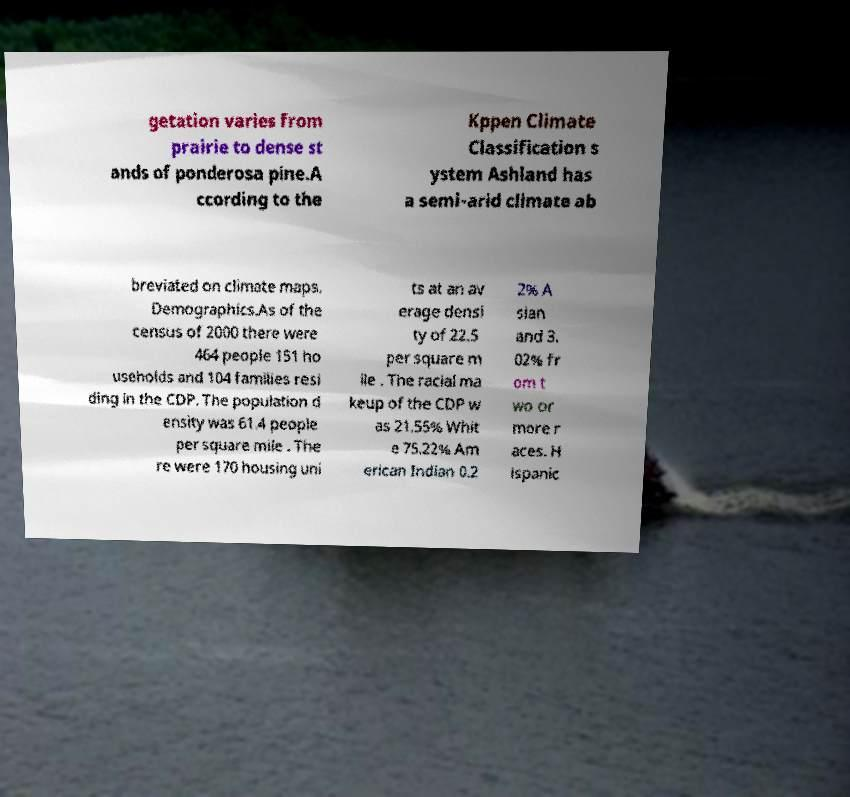There's text embedded in this image that I need extracted. Can you transcribe it verbatim? getation varies from prairie to dense st ands of ponderosa pine.A ccording to the Kppen Climate Classification s ystem Ashland has a semi-arid climate ab breviated on climate maps. Demographics.As of the census of 2000 there were 464 people 151 ho useholds and 104 families resi ding in the CDP. The population d ensity was 61.4 people per square mile . The re were 170 housing uni ts at an av erage densi ty of 22.5 per square m ile . The racial ma keup of the CDP w as 21.55% Whit e 75.22% Am erican Indian 0.2 2% A sian and 3. 02% fr om t wo or more r aces. H ispanic 